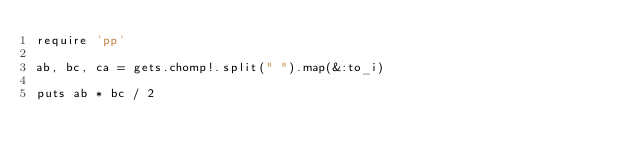Convert code to text. <code><loc_0><loc_0><loc_500><loc_500><_Ruby_>require 'pp'

ab, bc, ca = gets.chomp!.split(" ").map(&:to_i)

puts ab * bc / 2
</code> 